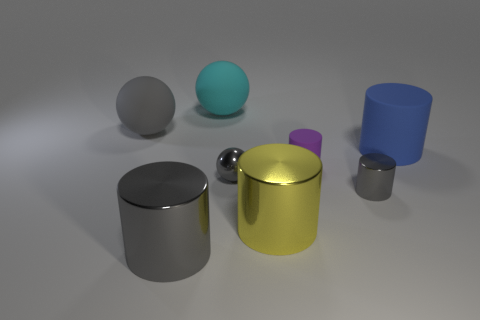Subtract all small shiny cylinders. How many cylinders are left? 4 Subtract 2 cylinders. How many cylinders are left? 3 Subtract all yellow cylinders. How many cylinders are left? 4 Subtract all green cylinders. Subtract all brown balls. How many cylinders are left? 5 Add 2 rubber objects. How many objects exist? 10 Subtract all cylinders. How many objects are left? 3 Subtract all red cubes. Subtract all purple objects. How many objects are left? 7 Add 1 tiny purple objects. How many tiny purple objects are left? 2 Add 4 shiny cylinders. How many shiny cylinders exist? 7 Subtract 0 red cylinders. How many objects are left? 8 